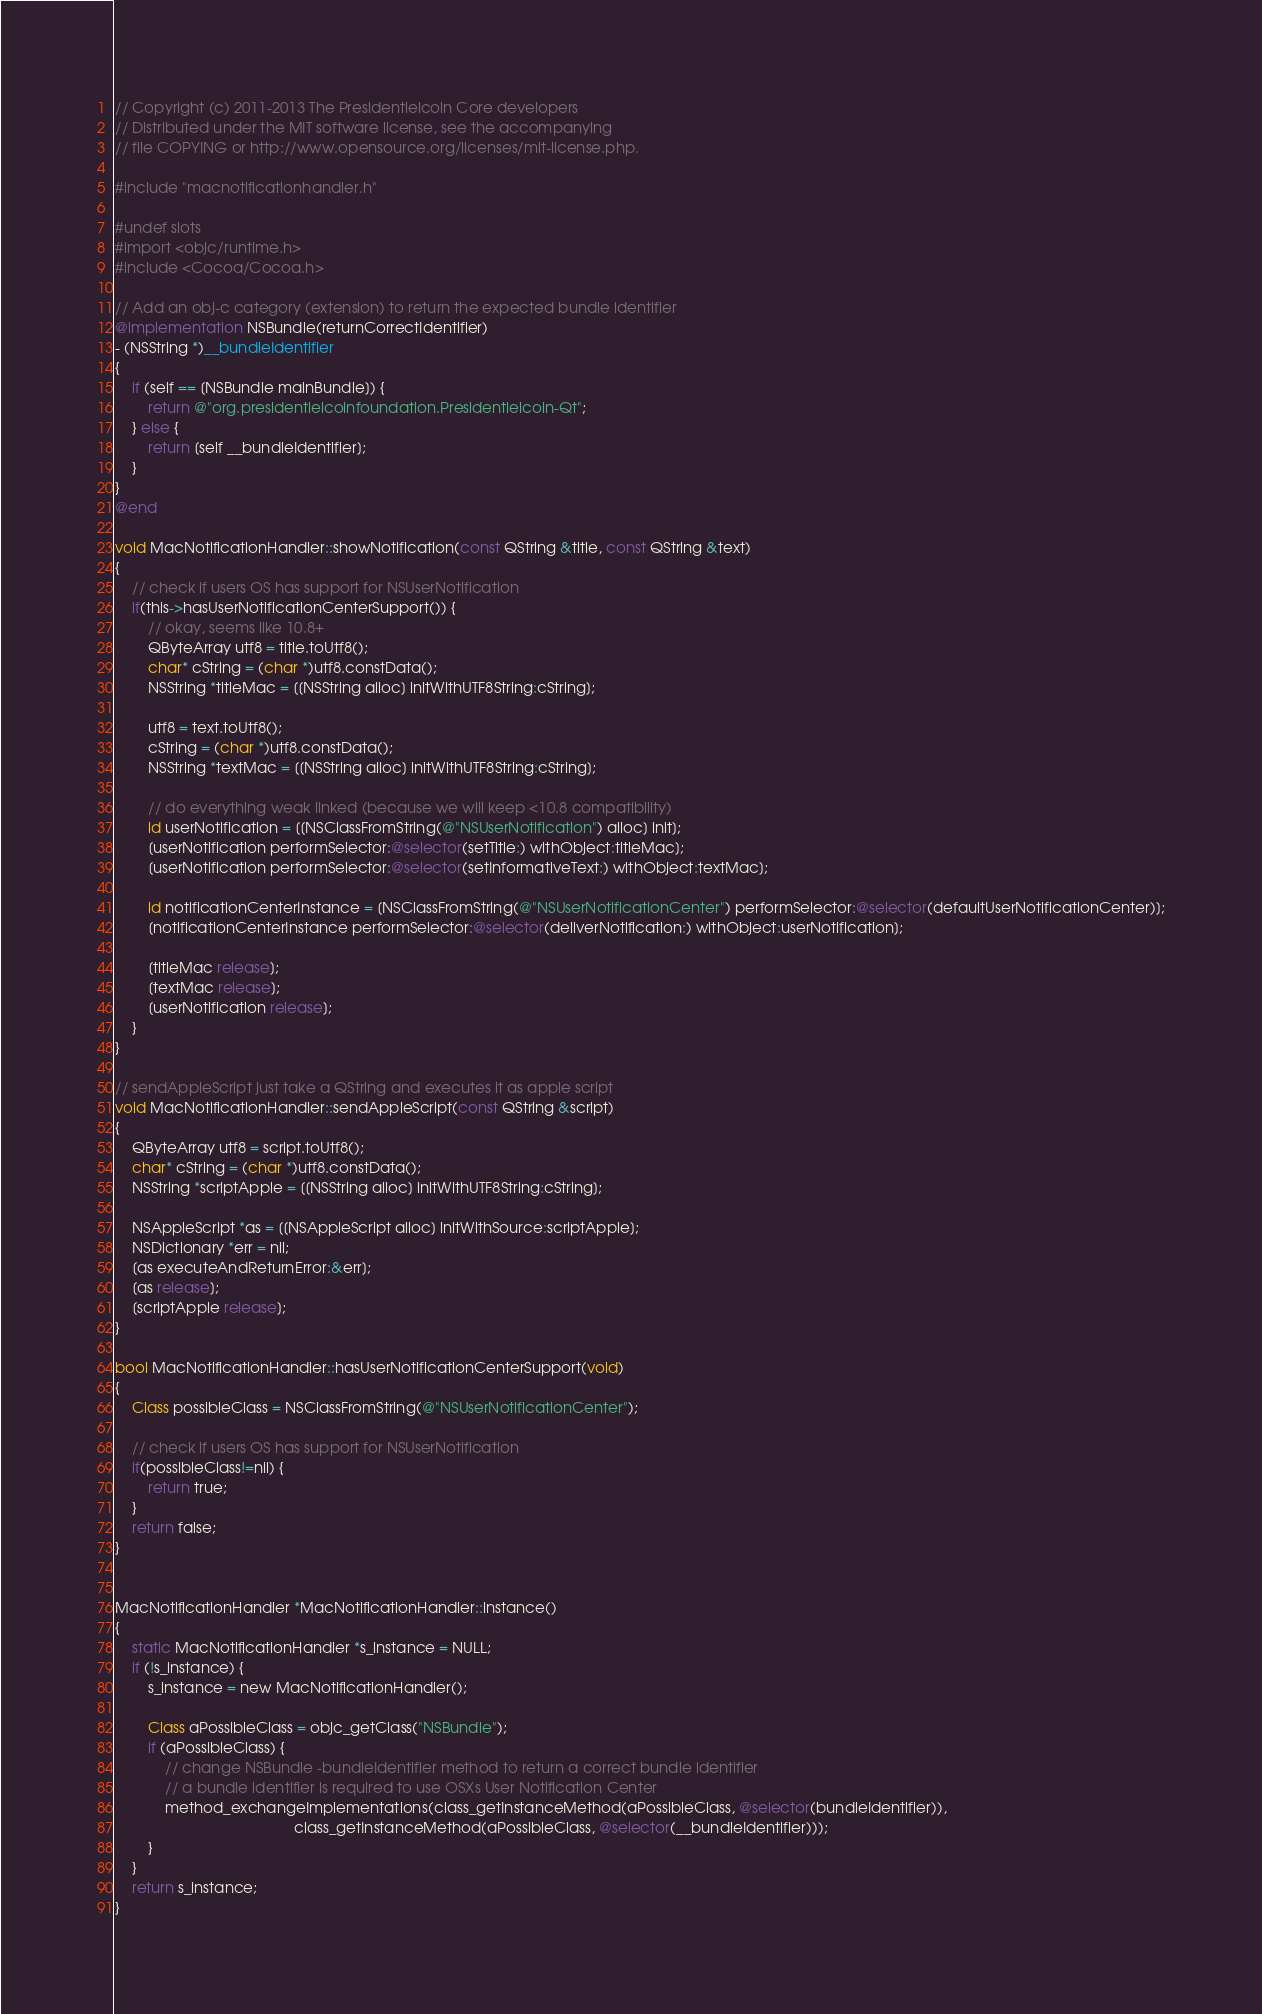<code> <loc_0><loc_0><loc_500><loc_500><_ObjectiveC_>// Copyright (c) 2011-2013 The Presidentielcoin Core developers
// Distributed under the MIT software license, see the accompanying
// file COPYING or http://www.opensource.org/licenses/mit-license.php.

#include "macnotificationhandler.h"

#undef slots
#import <objc/runtime.h>
#include <Cocoa/Cocoa.h>

// Add an obj-c category (extension) to return the expected bundle identifier
@implementation NSBundle(returnCorrectIdentifier)
- (NSString *)__bundleIdentifier
{
    if (self == [NSBundle mainBundle]) {
        return @"org.presidentielcoinfoundation.Presidentielcoin-Qt";
    } else {
        return [self __bundleIdentifier];
    }
}
@end

void MacNotificationHandler::showNotification(const QString &title, const QString &text)
{
    // check if users OS has support for NSUserNotification
    if(this->hasUserNotificationCenterSupport()) {
        // okay, seems like 10.8+
        QByteArray utf8 = title.toUtf8();
        char* cString = (char *)utf8.constData();
        NSString *titleMac = [[NSString alloc] initWithUTF8String:cString];

        utf8 = text.toUtf8();
        cString = (char *)utf8.constData();
        NSString *textMac = [[NSString alloc] initWithUTF8String:cString];

        // do everything weak linked (because we will keep <10.8 compatibility)
        id userNotification = [[NSClassFromString(@"NSUserNotification") alloc] init];
        [userNotification performSelector:@selector(setTitle:) withObject:titleMac];
        [userNotification performSelector:@selector(setInformativeText:) withObject:textMac];

        id notificationCenterInstance = [NSClassFromString(@"NSUserNotificationCenter") performSelector:@selector(defaultUserNotificationCenter)];
        [notificationCenterInstance performSelector:@selector(deliverNotification:) withObject:userNotification];

        [titleMac release];
        [textMac release];
        [userNotification release];
    }
}

// sendAppleScript just take a QString and executes it as apple script
void MacNotificationHandler::sendAppleScript(const QString &script)
{
    QByteArray utf8 = script.toUtf8();
    char* cString = (char *)utf8.constData();
    NSString *scriptApple = [[NSString alloc] initWithUTF8String:cString];

    NSAppleScript *as = [[NSAppleScript alloc] initWithSource:scriptApple];
    NSDictionary *err = nil;
    [as executeAndReturnError:&err];
    [as release];
    [scriptApple release];
}

bool MacNotificationHandler::hasUserNotificationCenterSupport(void)
{
    Class possibleClass = NSClassFromString(@"NSUserNotificationCenter");

    // check if users OS has support for NSUserNotification
    if(possibleClass!=nil) {
        return true;
    }
    return false;
}


MacNotificationHandler *MacNotificationHandler::instance()
{
    static MacNotificationHandler *s_instance = NULL;
    if (!s_instance) {
        s_instance = new MacNotificationHandler();
        
        Class aPossibleClass = objc_getClass("NSBundle");
        if (aPossibleClass) {
            // change NSBundle -bundleIdentifier method to return a correct bundle identifier
            // a bundle identifier is required to use OSXs User Notification Center
            method_exchangeImplementations(class_getInstanceMethod(aPossibleClass, @selector(bundleIdentifier)),
                                           class_getInstanceMethod(aPossibleClass, @selector(__bundleIdentifier)));
        }
    }
    return s_instance;
}
</code> 